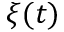<formula> <loc_0><loc_0><loc_500><loc_500>\xi ( t )</formula> 